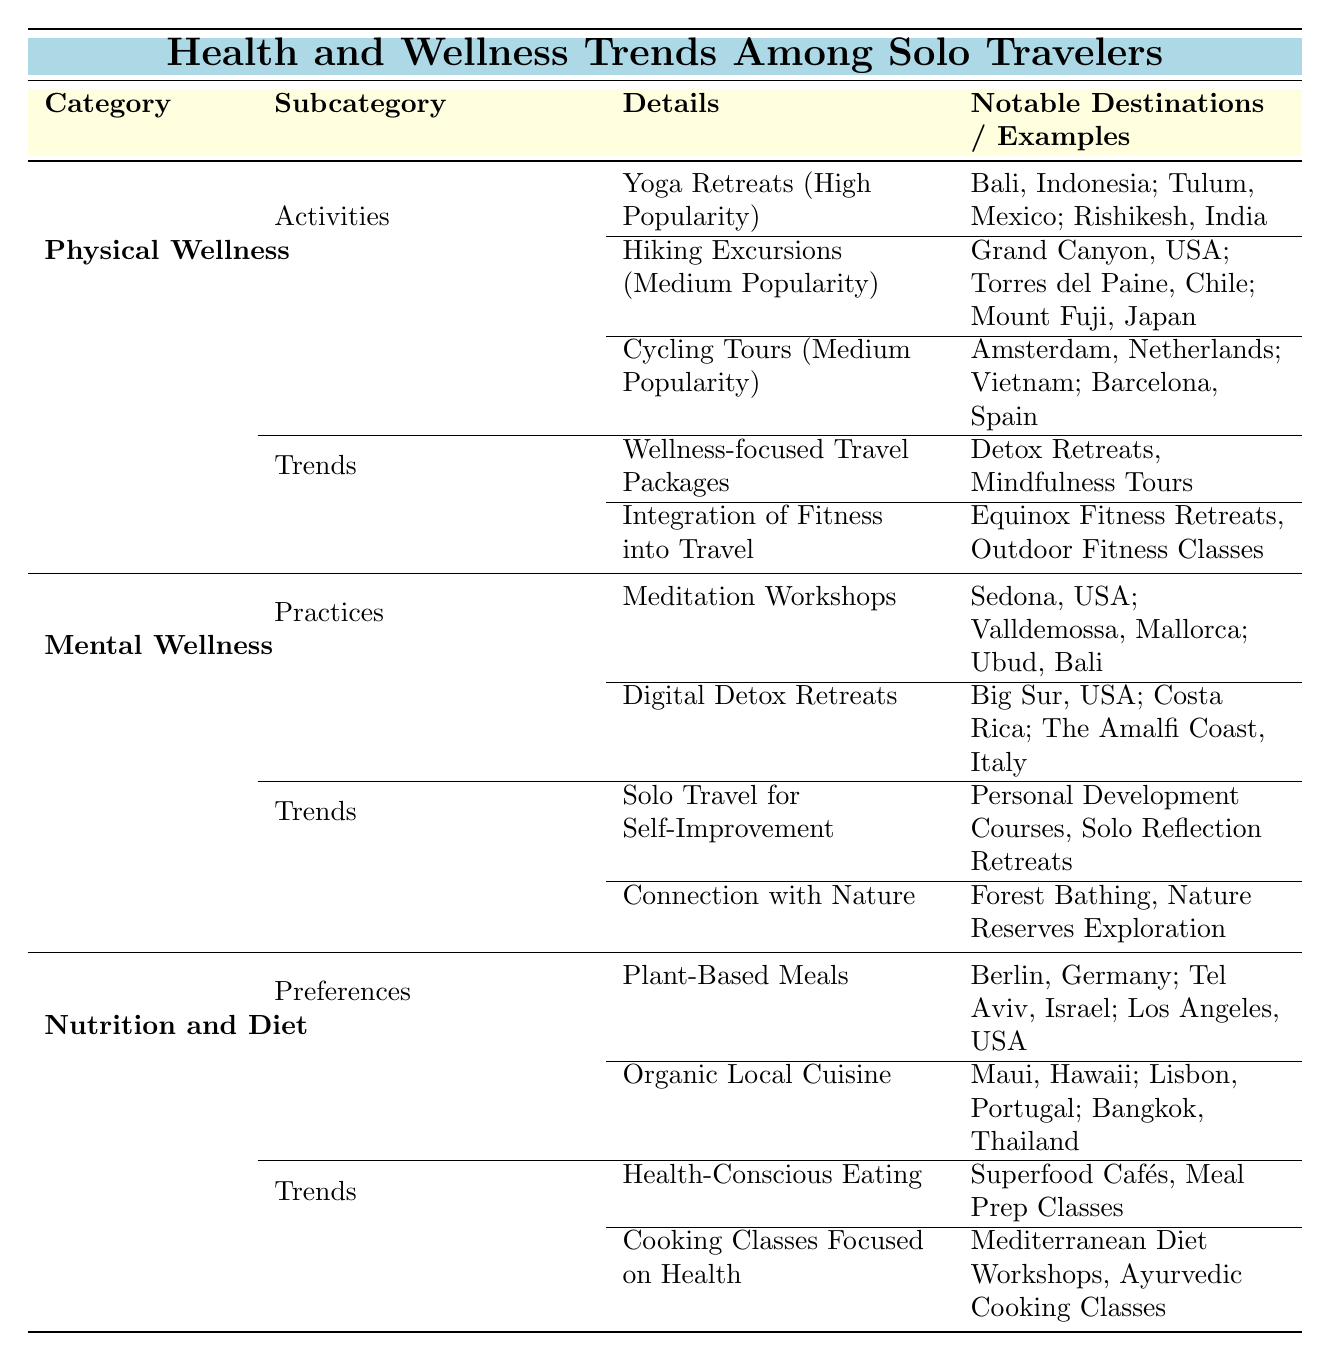What are the notable destinations for yoga retreats? The table lists three notable destinations for yoga retreats under Physical Wellness and Activities: Bali, Indonesia; Tulum, Mexico; and Rishikesh, India.
Answer: Bali, Indonesia; Tulum, Mexico; Rishikesh, India Is hiking excursions more popular than cycling tours? The popularity of hiking excursions is classified as medium, and the popularity of cycling tours is also classified as medium. Since both have the same popularity level, hiking excursions are not more popular than cycling tours.
Answer: No What are two trends associated with nutrition and diet? The table provides two trends under Nutrition and Diet: Health-Conscious Eating and Cooking Classes Focused on Health.
Answer: Health-Conscious Eating; Cooking Classes Focused on Health Which practice is focused on mindfulness and stress relief? The practice of Meditation Workshops is specifically mentioned in the table as focused on mindfulness and stress relief.
Answer: Meditation Workshops What is the average popularity level of the activities listed under Physical Wellness? Yoga retreats are classified as high popularity. Hiking excursions and cycling tours are both classified as medium popularity, so to calculate the average: high (considered as 3) + medium (considered as 2) + medium (considered as 2) = 7 total popularity levels, divided by 3 activities results in an average popularity level of about 2.33, which can be classified as medium.
Answer: Medium 